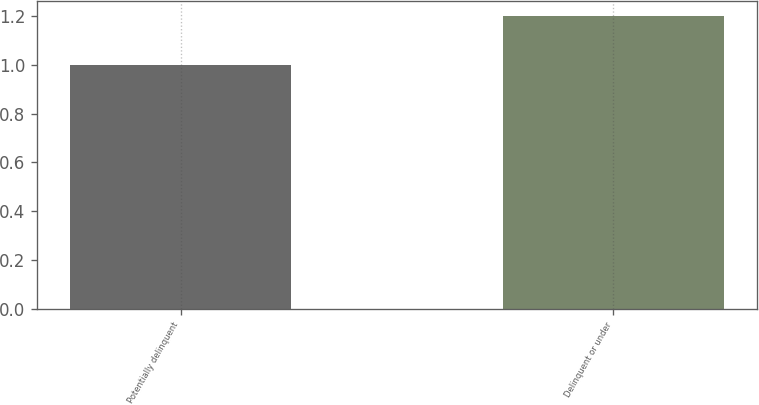<chart> <loc_0><loc_0><loc_500><loc_500><bar_chart><fcel>Potentially delinquent<fcel>Delinquent or under<nl><fcel>1<fcel>1.2<nl></chart> 